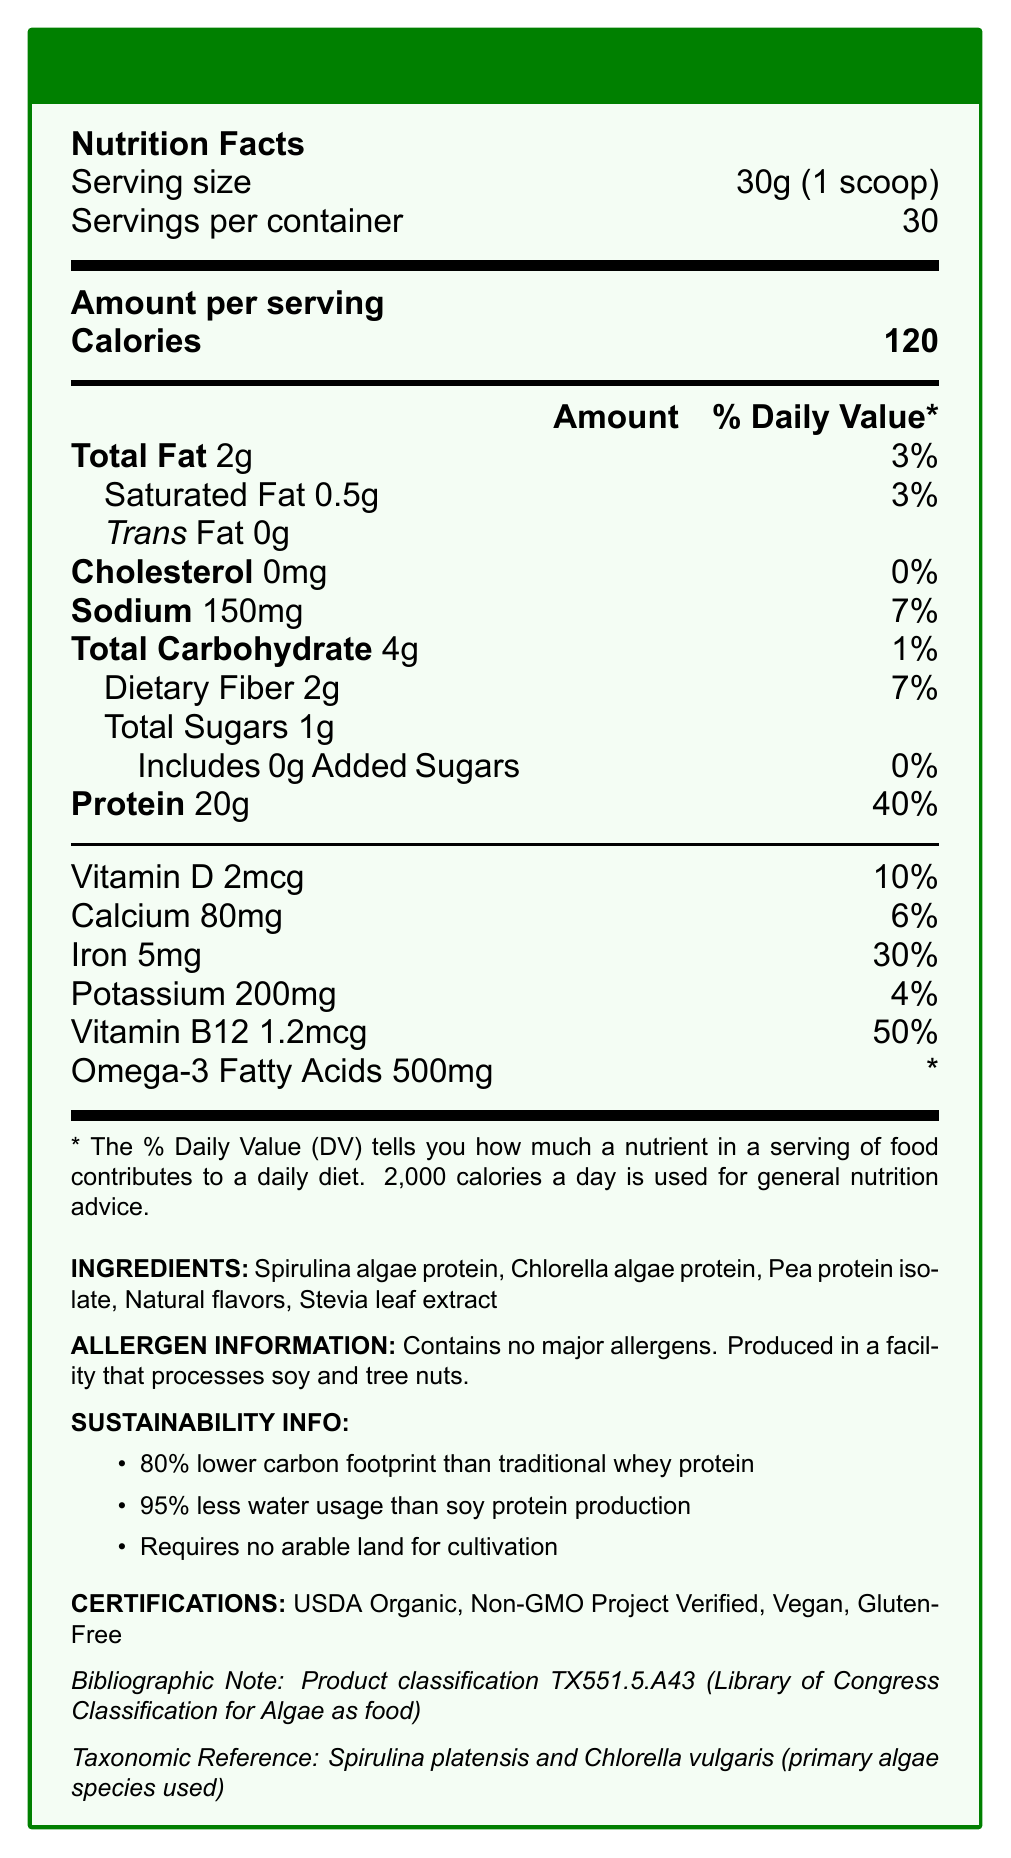what is the serving size for EcoAlgae Protein Plus? The serving size for EcoAlgae Protein Plus is clearly mentioned as 30g or 1 scoop in the Nutrition Facts section.
Answer: 30g (1 scoop) how many servings are there per container? The document states that there are 30 servings per container.
Answer: 30 servings how many calories are in one serving? The document lists the calories per serving as 120.
Answer: 120 calories what is the total fat content per serving? The document states that the total fat content per serving is 2 grams.
Answer: 2g what are the primary algae species used in this product? The taxonomic reference section mentions Spirulina platensis and Chlorella vulgaris as the primary algae species.
Answer: Spirulina platensis and Chlorella vulgaris which macronutrient has the highest daily value percentage per serving? A. Total Fat B. Sodium C. Dietary Fiber D. Protein The section shows protein with a daily value of 40%, which is the highest among the listed macronutrients.
Answer: D which vitamin has the highest daily value percentage per serving? A. Vitamin D B. Calcium C. Iron D. Vitamin B12 Vitamin B12 has a daily value of 50% per serving, which is the highest among the listed vitamins and minerals.
Answer: D does the product contain any major allergens? The allergen information mentions that the product contains no major allergens.
Answer: No is this product appropriate for vegans? The document includes a certification section listing the product as Vegan.
Answer: Yes how does the carbon footprint of this product compare to traditional whey protein? The sustainability information states that the carbon footprint is 80% lower than traditional whey protein.
Answer: 80% lower how much water usage is reduced in comparison to soy protein production? The document indicates that water usage is 95% less than soy protein production.
Answer: 95% less summarize the main idea of this document. EcoAlgae Protein Plus is designed to be both nutrient-rich and eco-friendly. It includes algae-based proteins, has high protein content, and is certified organic, vegan, non-GMO, and gluten-free. Additionally, it significantly reduces carbon footprint and water usage compared to more conventional protein sources.
Answer: EcoAlgae Protein Plus is a nutrient-dense, sustainable algae-based protein powder. It contains 20g of protein per serving, with certifications like USDA Organic and Vegan. The manufacturing of this product is eco-friendly, having an 80% lower carbon footprint and 95% less water usage than traditional protein sources, and it requires no arable land. what is the taxonomic classification of the algae used in the product? The document mentions the common names and species of the algae but does not provide a full taxonomic classification with family or order information, so we cannot offer a complete taxonomic classification from the given information.
Answer: Cannot be determined 